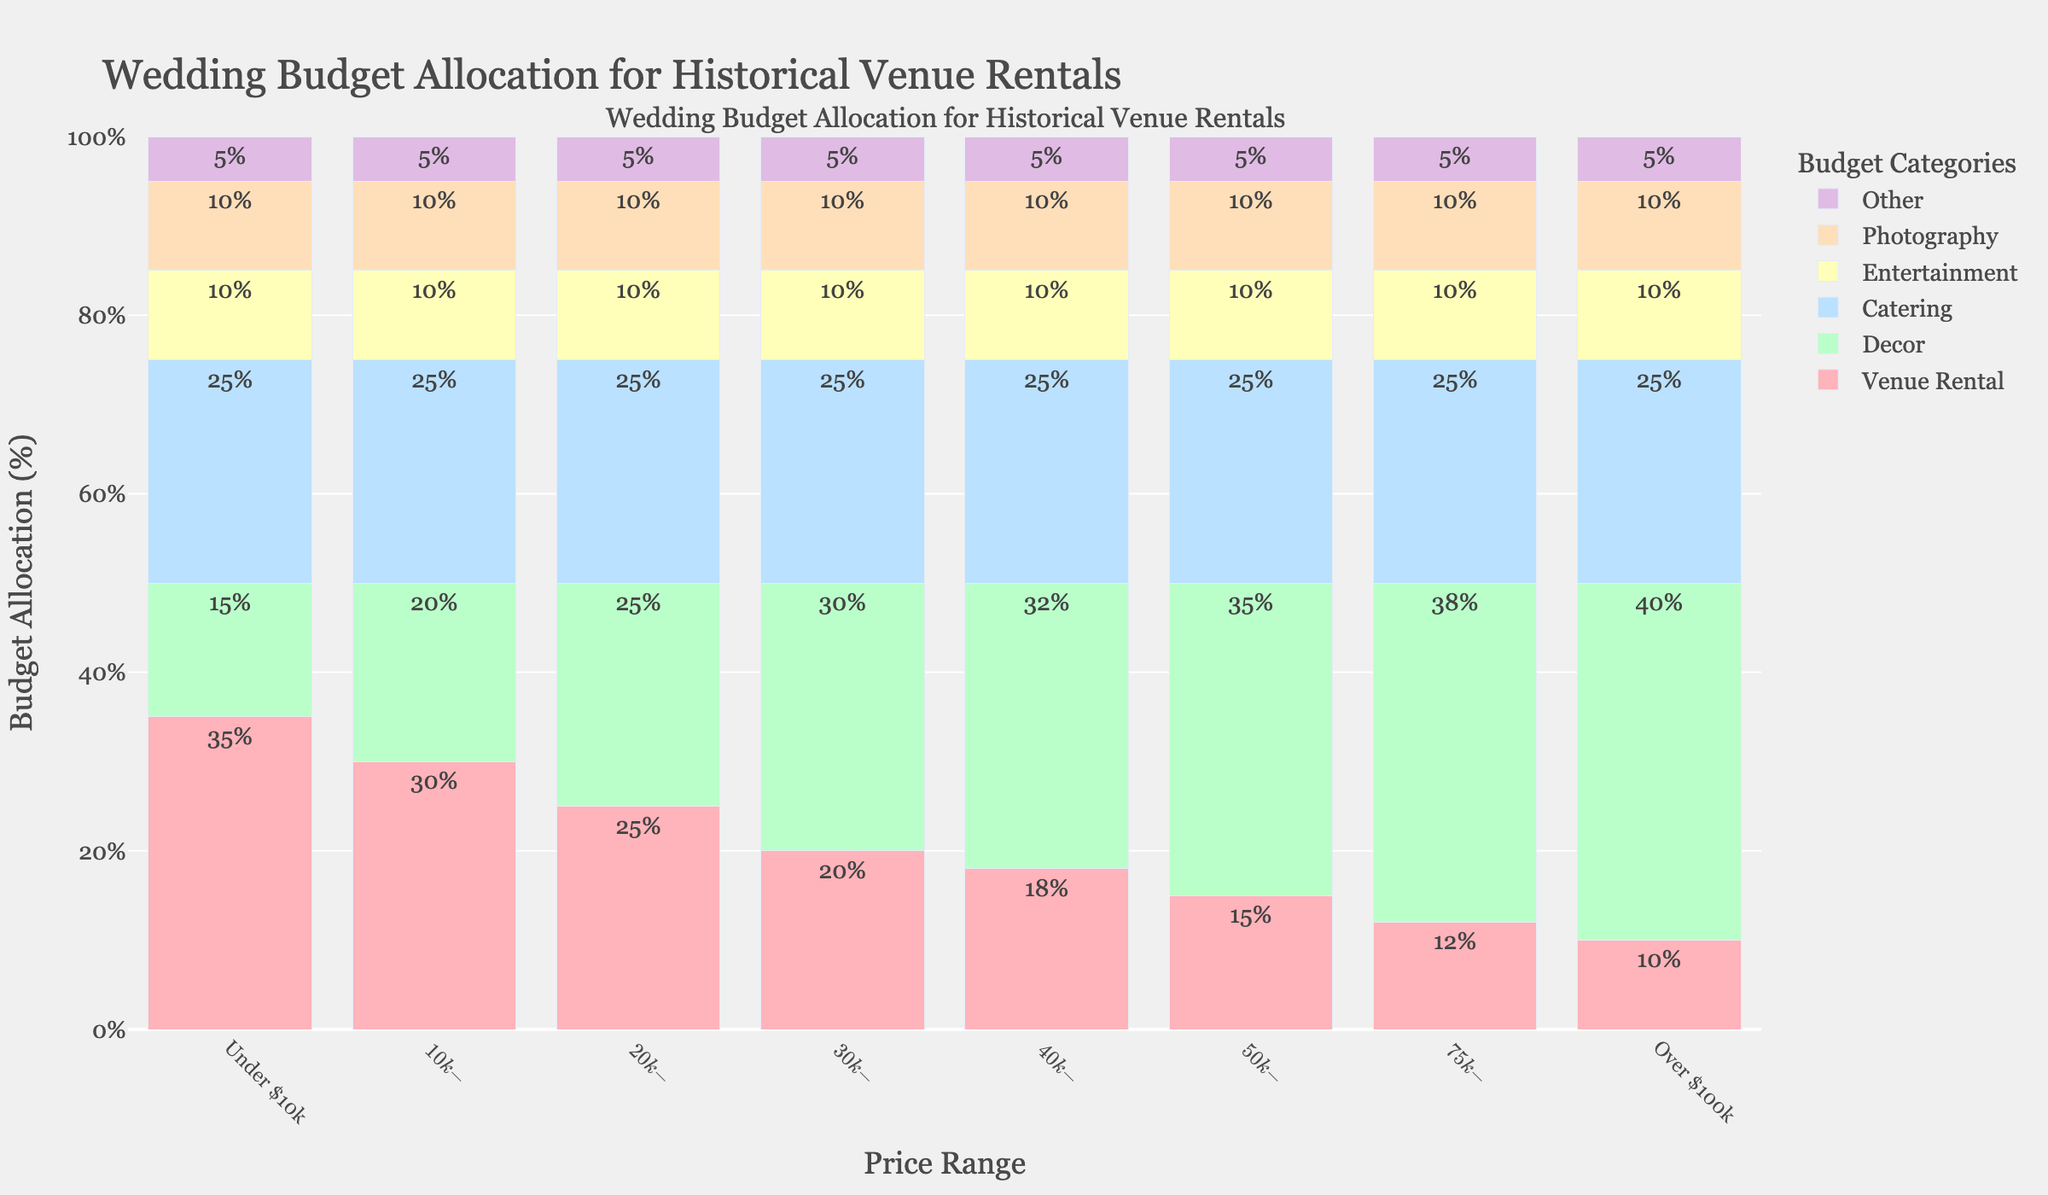How does the percentage allocated to venue rental change as the price range increases? As the price range increases, the percentage of the budget allocated to venue rental decreases consistently. It starts at 35% in the "Under $10k" range and drops to 10% in the "Over $100k" range.
Answer: The percentage decreases Which price range allocates the highest percentage to decor? Looking at the figure, the "Over $100k" price range allocates the highest percentage to decor, at 40%.
Answer: Over $100k Is there any price range where catering does not represent 25% of the budget? Observing the figure, catering consistently represents 25% of the budget across all price ranges.
Answer: No By how much does the venue rental percentage decrease from the "Under $10k" to the "$50k-$75k" price range? The percentage for venue rental under $10k is 35%. In the $50k-$75k range, it is 15%. So, the decrease is 35% - 15% = 20%.
Answer: 20% What percentage of the budget is allocated to other categories for the "Under $10k" and "$10k-$20k" price ranges combined? For "Under $10k," the 'Other' category is 5% and for "$10k-$20k" it is also 5%. Combining both, it remains 5%, as 'Other' is consistently 5% across all ranges.
Answer: 5% Which category does not vary in percentage allocation across different price ranges? Entertainment, photography, and other categories do not vary as they are consistently at 10%, 10%, and 5% respectively across all price ranges.
Answer: Entertainment, Photography, and Other What is the combined percentage for decor and venue rental in the "$30k-$40k" price range? In the "$30k-$40k" range, decor is 30% and venue rental is 20%. Combined, this is 30% + 20% = 50%.
Answer: 50% How does the allocation for entertainment compare between the "$20k-$30k" and "$75k-$100k" price ranges? The percentage allocated to entertainment remains the same at 10% for both the "$20k-$30k" and "$75k-$100k" price ranges.
Answer: It is the same Does any category show an increase and then a decrease in allocation with increasing price range? The venue rental category shows this pattern. It increases initially up to "$10k-$20k", then consistently decreases as the price range increases further.
Answer: Venue Rental What is the percentage difference in decor allocation between the "Under $10k" and the "Over $100k" price ranges? In the "Under $10k" range, decor allocation is 15%, whereas in the "Over $100k" range it is 40%. The difference is 40% - 15% = 25%.
Answer: 25% 